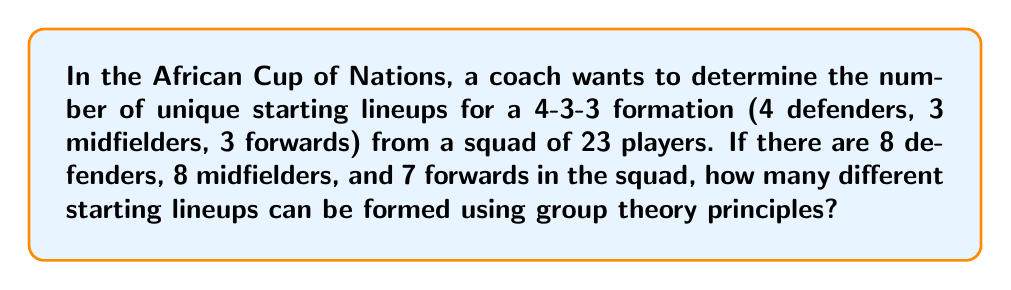What is the answer to this math problem? To solve this problem, we'll use the concept of combinations from group theory. We need to calculate the number of ways to choose players for each position group and then multiply these together.

1. For defenders:
   We need to choose 4 defenders from 8 available.
   This can be represented as $\binom{8}{4}$.
   $$\binom{8}{4} = \frac{8!}{4!(8-4)!} = \frac{8!}{4!4!} = 70$$

2. For midfielders:
   We need to choose 3 midfielders from 8 available.
   This can be represented as $\binom{8}{3}$.
   $$\binom{8}{3} = \frac{8!}{3!(8-3)!} = \frac{8!}{3!5!} = 56$$

3. For forwards:
   We need to choose 3 forwards from 7 available.
   This can be represented as $\binom{7}{3}$.
   $$\binom{7}{3} = \frac{7!}{3!(7-3)!} = \frac{7!}{3!4!} = 35$$

4. To get the total number of possible lineups, we multiply these together:
   $$70 \times 56 \times 35 = 137,200$$

This result represents the order of the group of all possible lineups, which is the product of the orders of the subgroups (defenders, midfielders, and forwards).
Answer: 137,200 